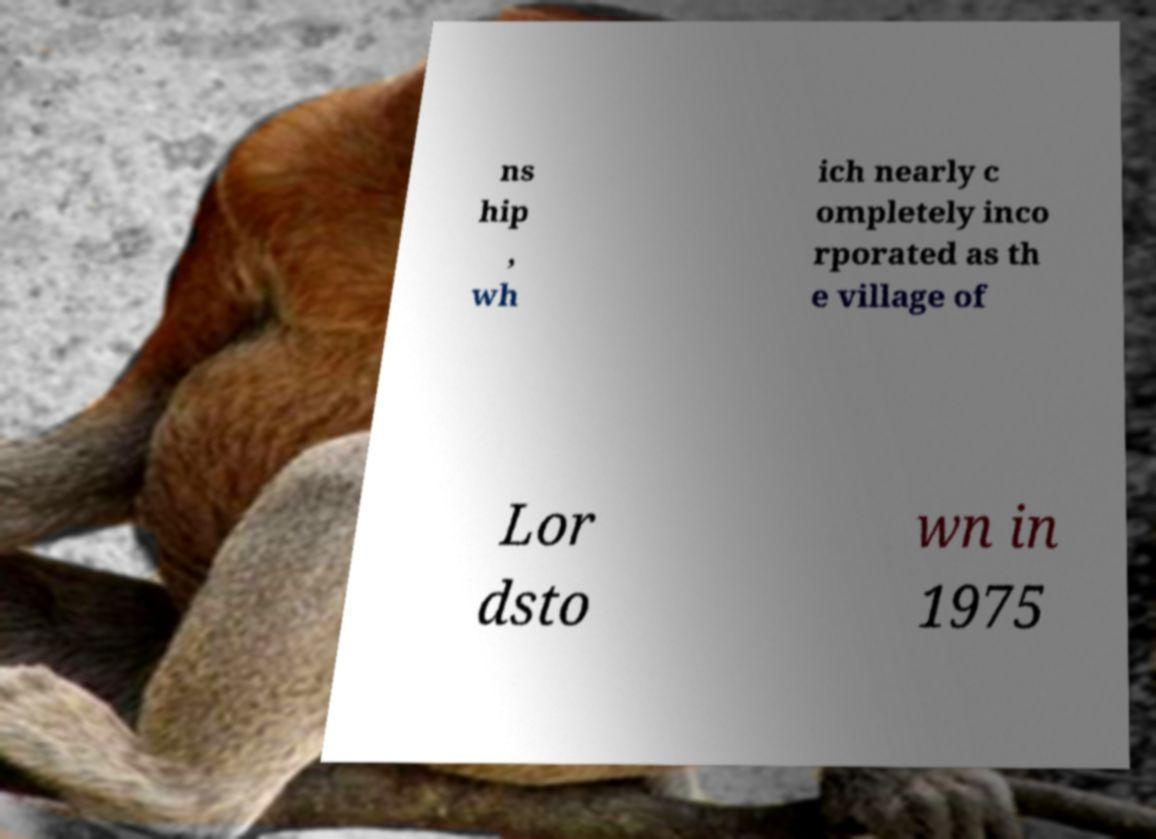Please read and relay the text visible in this image. What does it say? ns hip , wh ich nearly c ompletely inco rporated as th e village of Lor dsto wn in 1975 